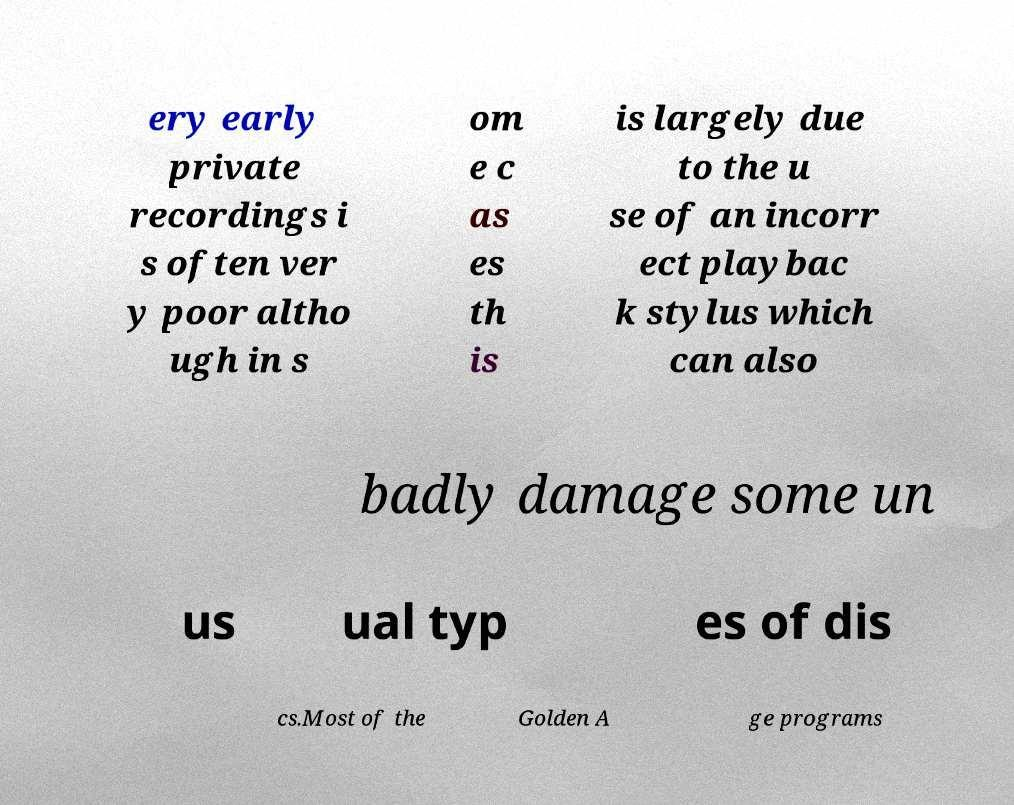Please read and relay the text visible in this image. What does it say? ery early private recordings i s often ver y poor altho ugh in s om e c as es th is is largely due to the u se of an incorr ect playbac k stylus which can also badly damage some un us ual typ es of dis cs.Most of the Golden A ge programs 